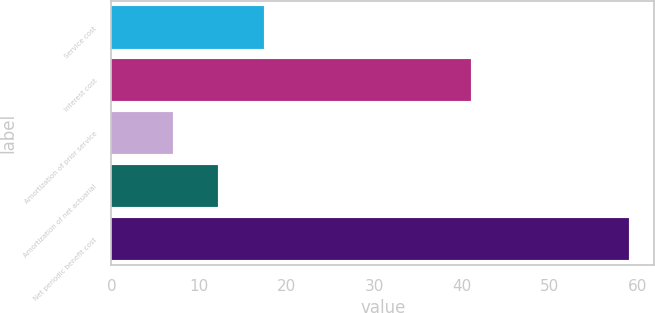<chart> <loc_0><loc_0><loc_500><loc_500><bar_chart><fcel>Service cost<fcel>Interest cost<fcel>Amortization of prior service<fcel>Amortization of net actuarial<fcel>Net periodic benefit cost<nl><fcel>17.4<fcel>41<fcel>7<fcel>12.2<fcel>59<nl></chart> 